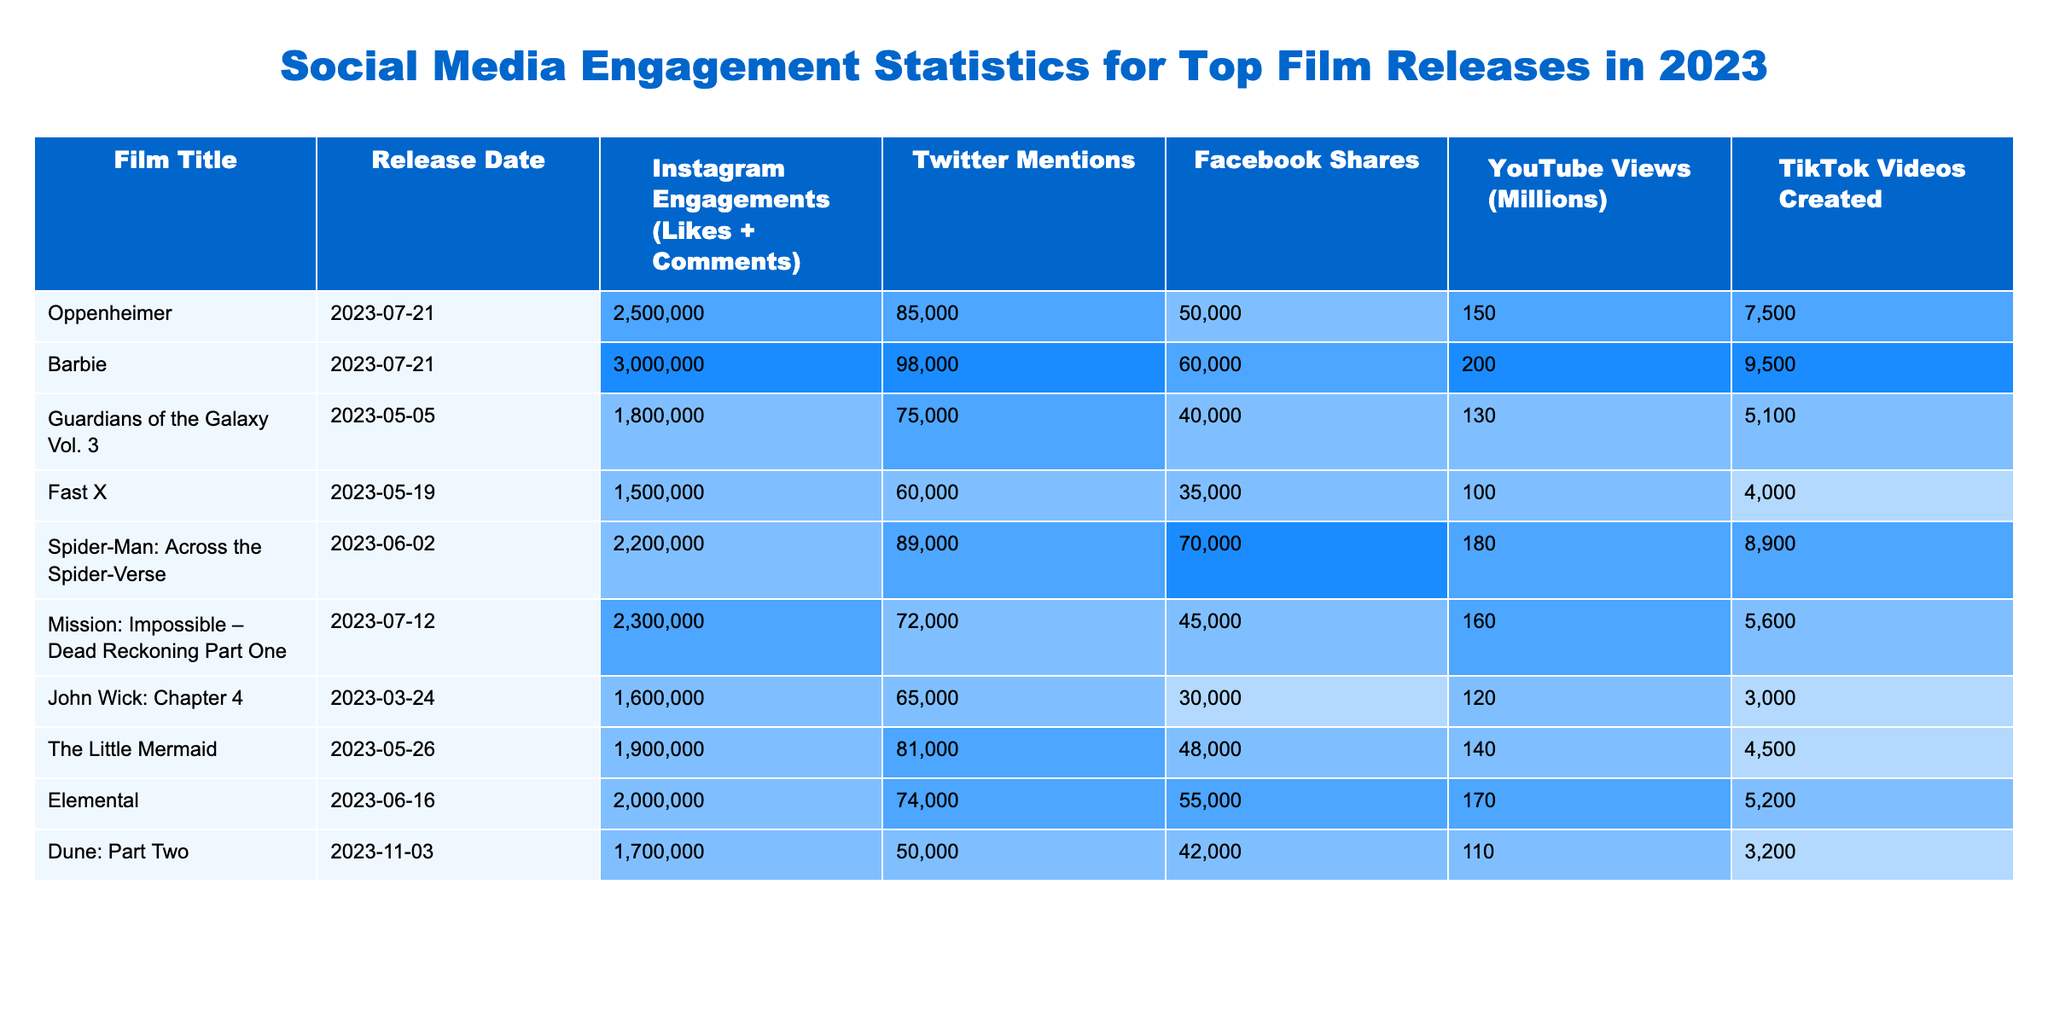What film had the highest Instagram engagements in 2023? By inspecting the Instagram Engagements column, we can identify the film with the highest value. "Barbie" has 3,000,000 engagements, which is greater than all others listed.
Answer: Barbie How many YouTube views did "Oppenheimer" receive in millions? The table indicates that "Oppenheimer" received 150 million views according to the YouTube Views column.
Answer: 150 Which film had the lowest number of Facebook Shares? Looking at the Facebook Shares column, "Fast X" has the lowest number of shares with 35,000.
Answer: Fast X What is the total number of Twitter Mentions for all films combined? To find this, sum all Twitter Mentions: 85,000 + 98,000 + 75,000 + 60,000 + 89,000 + 72,000 + 65,000 + 81,000 + 74,000 + 50,000 =  1,074,000.
Answer: 1,074,000 Which film had more TikTok Videos created: "John Wick: Chapter 4" or "Elemental"? "John Wick: Chapter 4" had 3,000 videos, while "Elemental" had 5,200 videos; hence, "Elemental" had more.
Answer: Elemental What is the average number of Instagram engagements for the films released on July 21, 2023? The films released on that date are "Oppenheimer" and "Barbie". The engagements are 2,500,000 and 3,000,000. The average is (2,500,000 + 3,000,000) / 2 = 2,750,000.
Answer: 2,750,000 Is the count of YouTube views for "Fast X" greater than the combined views of "Dune: Part Two" and "Oppenheimer"? "Fast X" has 100 million views, while combining "Dune: Part Two" (110 million) and "Oppenheimer" (150 million), we have 110 + 150 = 260 million. Since 100 million is less than 260 million, the statement is false.
Answer: No Which film had the highest engagement rate on Instagram relative to its release date? Engagement rates are calculated regarding the number of engagements; "Barbie" had the highest with 3,000,000 engagements on July 21, making it relatively timely and impactful in its social media strategy.
Answer: Barbie What is the difference in Facebook Shares between "Spider-Man: Across the Spider-Verse" and "Guardians of the Galaxy Vol. 3"? "Spider-Man: Across the Spider-Verse" had 70,000 shares while "Guardians of the Galaxy Vol. 3" had 40,000 shares. The difference is 70,000 - 40,000 = 30,000.
Answer: 30,000 Which film had the most combined social media interactions (Instagram engagements, Twitter mentions, Facebook shares)? For the total, sum these for "Barbie": (3,000,000 + 98,000 + 60,000) = 3,158,000. No other film surpassed this combined total, making it the highest.
Answer: Barbie How many films had more than 8,000 TikTok videos created? Examining the TikTok Videos column, "Barbie," "Spider-Man: Across the Spider-Verse," and "Elemental" all had greater than 8,000 created videos. This totals to 3 films.
Answer: 3 